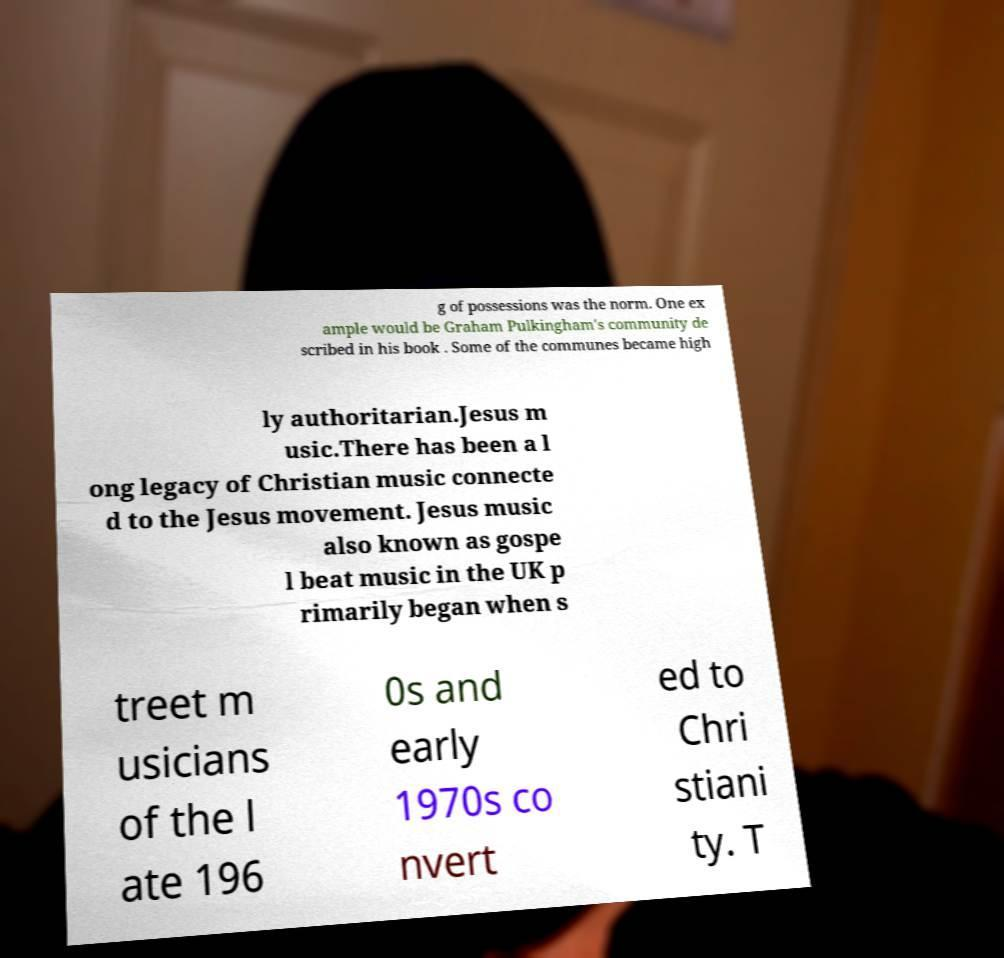Can you accurately transcribe the text from the provided image for me? g of possessions was the norm. One ex ample would be Graham Pulkingham's community de scribed in his book . Some of the communes became high ly authoritarian.Jesus m usic.There has been a l ong legacy of Christian music connecte d to the Jesus movement. Jesus music also known as gospe l beat music in the UK p rimarily began when s treet m usicians of the l ate 196 0s and early 1970s co nvert ed to Chri stiani ty. T 